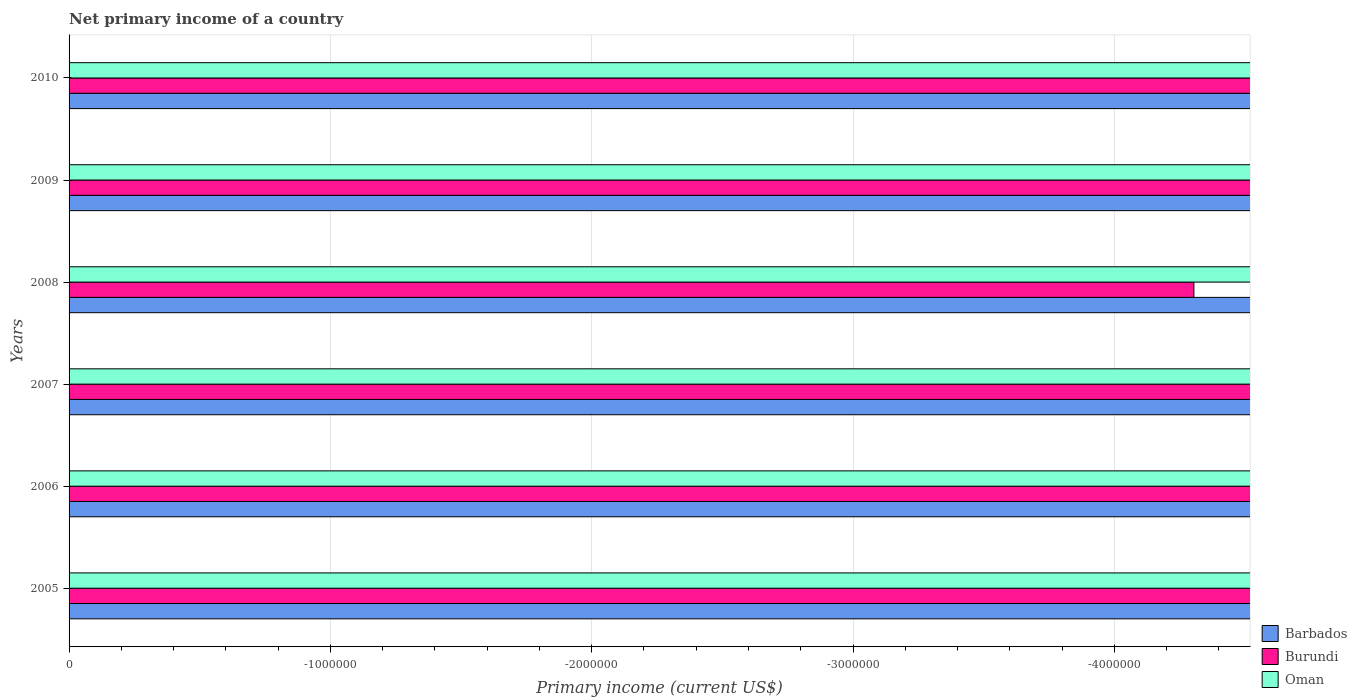What is the label of the 3rd group of bars from the top?
Your answer should be compact. 2008. What is the total primary income in Burundi in the graph?
Offer a terse response. 0. What is the average primary income in Burundi per year?
Give a very brief answer. 0. How many years are there in the graph?
Provide a succinct answer. 6. What is the difference between two consecutive major ticks on the X-axis?
Provide a short and direct response. 1.00e+06. Are the values on the major ticks of X-axis written in scientific E-notation?
Your response must be concise. No. Does the graph contain any zero values?
Provide a short and direct response. Yes. Does the graph contain grids?
Offer a terse response. Yes. How are the legend labels stacked?
Make the answer very short. Vertical. What is the title of the graph?
Offer a terse response. Net primary income of a country. What is the label or title of the X-axis?
Offer a terse response. Primary income (current US$). What is the Primary income (current US$) in Barbados in 2005?
Offer a terse response. 0. What is the Primary income (current US$) of Barbados in 2006?
Your answer should be very brief. 0. What is the Primary income (current US$) in Oman in 2006?
Give a very brief answer. 0. What is the Primary income (current US$) in Oman in 2007?
Your response must be concise. 0. What is the Primary income (current US$) of Burundi in 2009?
Keep it short and to the point. 0. What is the Primary income (current US$) of Barbados in 2010?
Provide a succinct answer. 0. What is the total Primary income (current US$) in Barbados in the graph?
Your answer should be compact. 0. What is the average Primary income (current US$) in Barbados per year?
Provide a short and direct response. 0. What is the average Primary income (current US$) in Burundi per year?
Offer a very short reply. 0. 